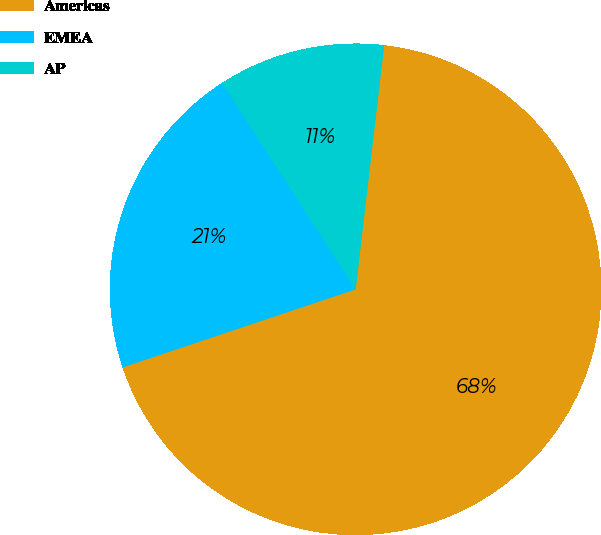Convert chart. <chart><loc_0><loc_0><loc_500><loc_500><pie_chart><fcel>Americas<fcel>EMEA<fcel>AP<nl><fcel>68.0%<fcel>21.0%<fcel>11.0%<nl></chart> 